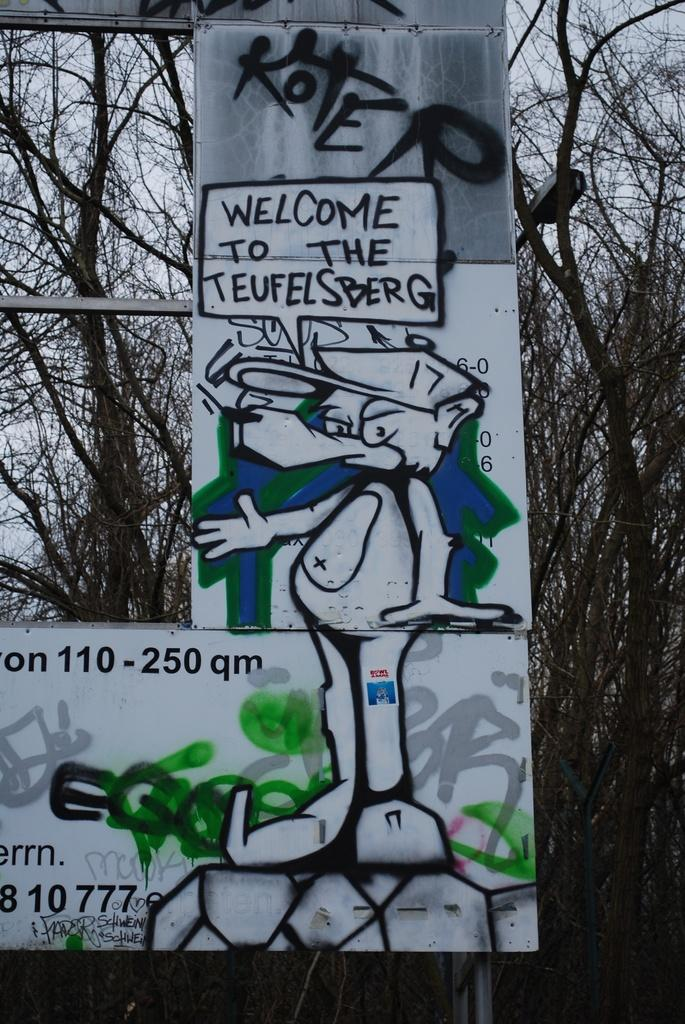What objects can be seen in the image? There are boards and a pole in the image. What can be seen in the background of the image? There are trees, light, and the sky visible in the background of the image. Where is the representative's nest located in the image? There is no representative or nest present in the image. 